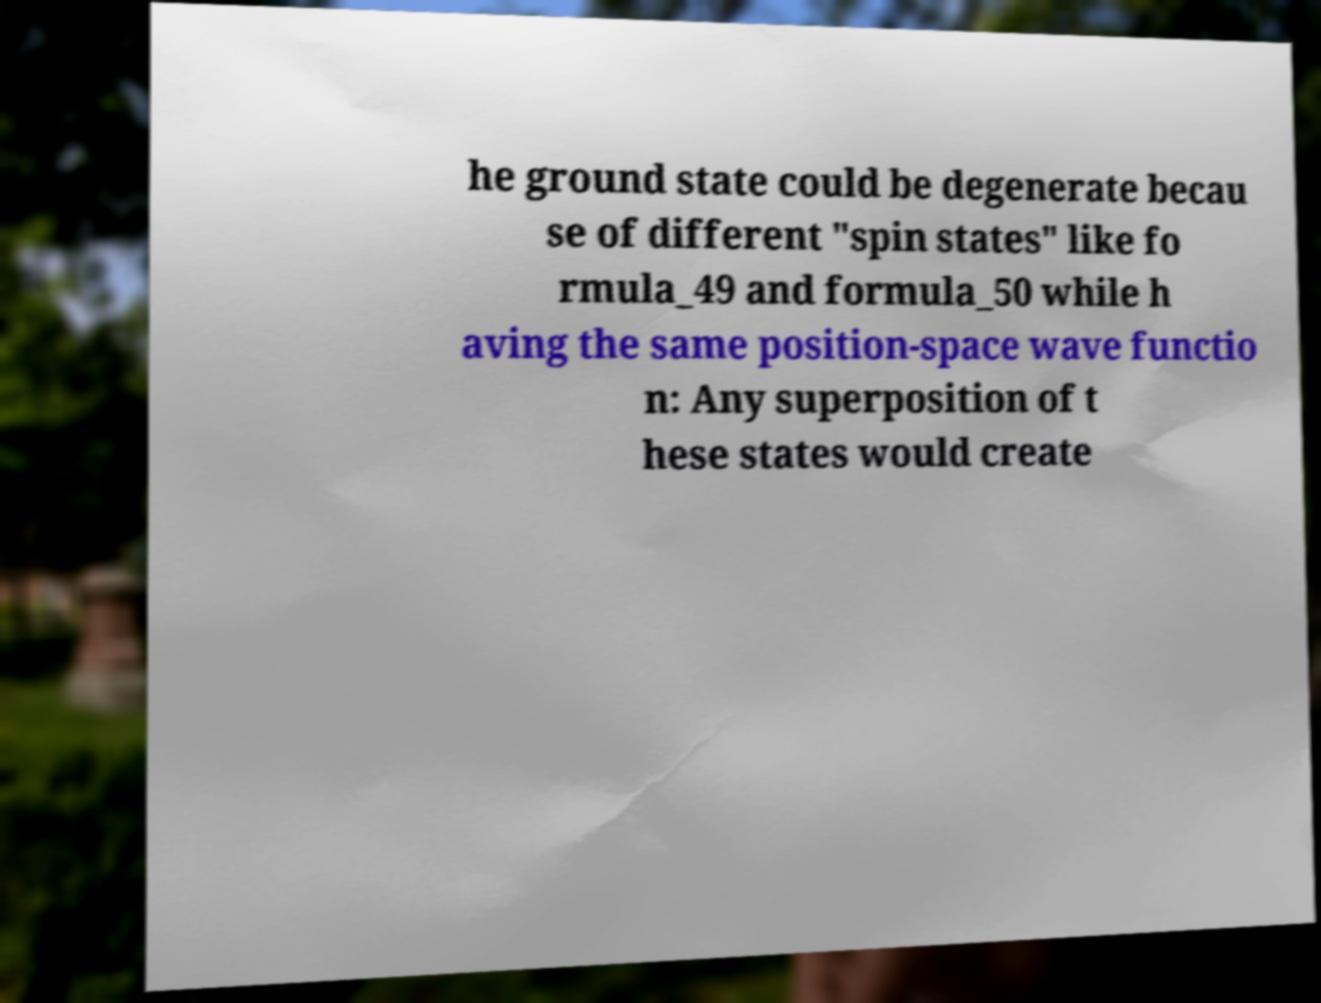For documentation purposes, I need the text within this image transcribed. Could you provide that? he ground state could be degenerate becau se of different "spin states" like fo rmula_49 and formula_50 while h aving the same position-space wave functio n: Any superposition of t hese states would create 